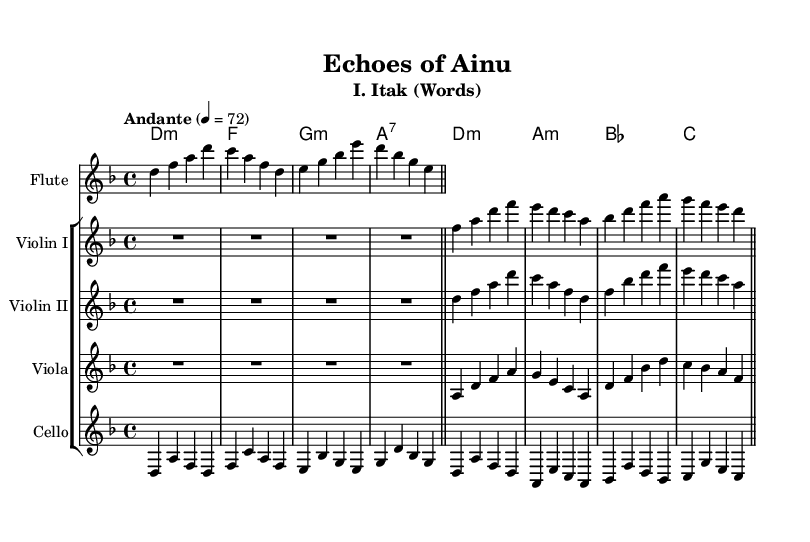What is the key signature of this music? The key signature indicated in the sheet music is one flat, which represents the key of D minor. This is identified at the beginning of the staff where the key signature is notated.
Answer: D minor What is the time signature of this music? The time signature is displayed at the beginning of the sheet music and is shown as a fraction. In this case, it is 4 over 4, meaning there are four beats in a measure and a quarter note receives one beat.
Answer: 4/4 What tempo indication is present in this sheet music? The tempo marking "Andante" is found at the beginning and followed by a metronome mark of 72, indicating a moderate pace. This can be identified in the tempo indication section of the score.
Answer: Andante, 72 Which instrument plays the first melodic line? The flute is the first instrument to enter with a melodic line, as seen at the beginning of the music score where the flute staff is presented first.
Answer: Flute How many measures are there in the whole score? By counting the measures indicated by the vertical bar lines throughout the score for all instruments, there is a total of eight measures. Each instrument continues the melody in these measures, depicting the entire musical section.
Answer: Eight What is the final chord of the piece? The last chord shown in the chord section at the end of the score is a C major chord, which typically resolves harmonically and can be confirmed by looking at the final notation of the chord progression.
Answer: C Which language elements is the symphony inspired by? The title of the symphony "Echoes of Ainu" suggests that the symphony incorporates linguistic elements from the Ainu language, which is an endangered language native to Japan. This thematic element is inferred from the title itself.
Answer: Ainu 